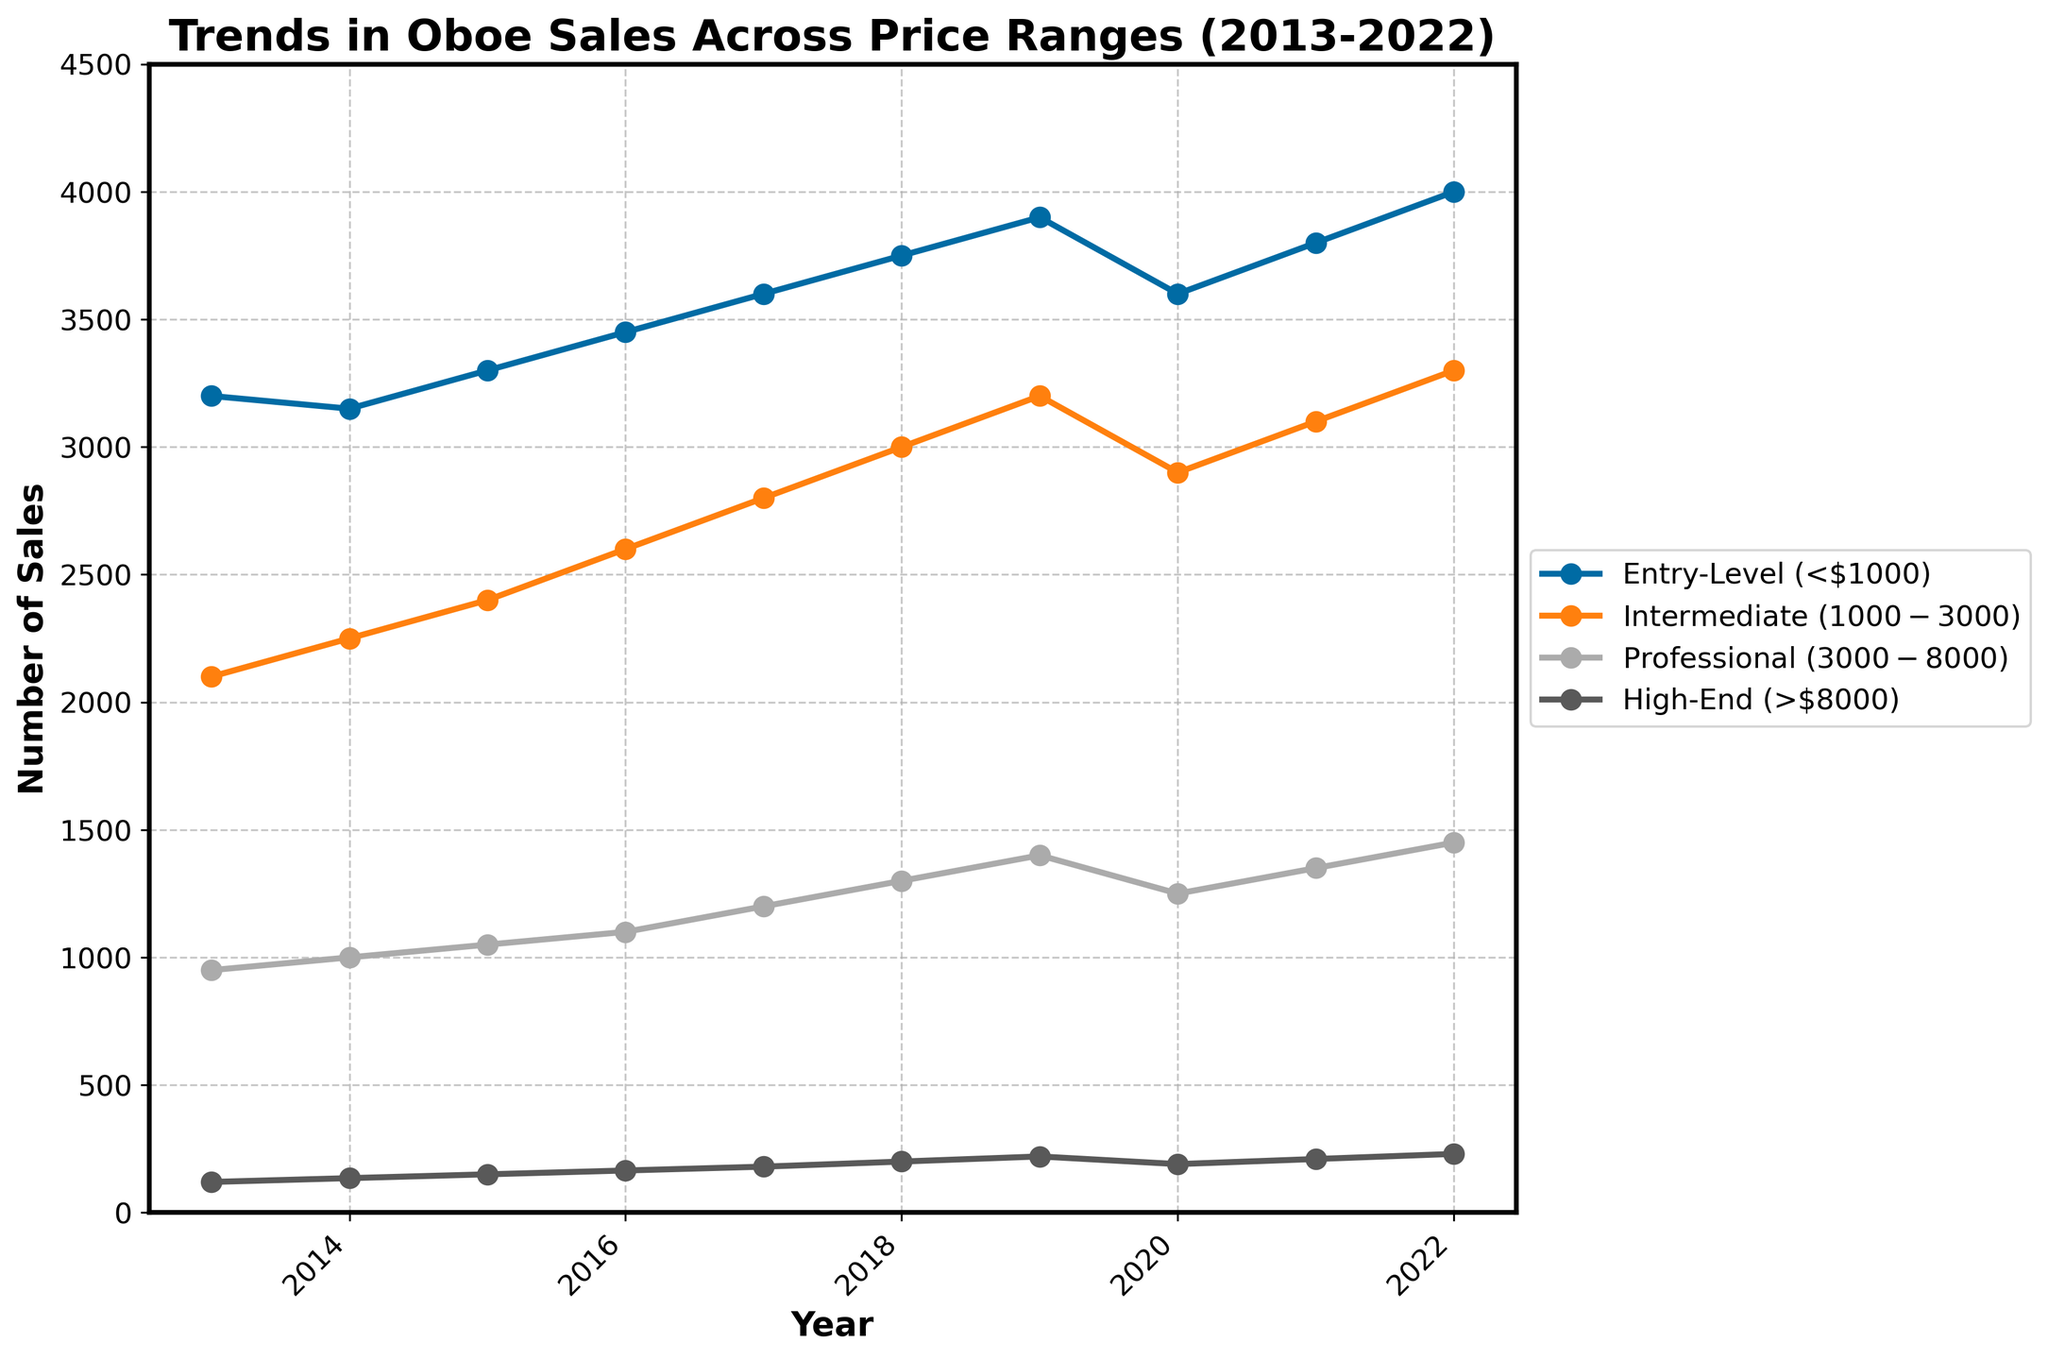When did Entry-Level oboe sales reach their peak during the given period? To find the peak year for Entry-Level oboe sales, look at the respective data line and identify the highest point. In this case, the highest number of entries for Entry-Level sales is 4000 in 2022.
Answer: 2022 Which price range saw the largest increase in sales from 2013 to 2022? To determine the price range with the largest increase in sales, calculate the difference between 2022 and 2013 sales for each price range. Entry-Level increased by 800 (4000-3200), Intermediate by 1200 (3300-2100), Professional by 500 (1450-950), and High-End by 110 (230-120). The Intermediate price range had the largest increase.
Answer: Intermediate ($1000-$3000) By how much did the sales of Professional oboes change from 2019 to 2020? Examine the data points for Professional oboes in 2019 and 2020: 1400 in 2019 and 1250 in 2020. Calculate the difference: 1400 - 1250 = 150.
Answer: Decreased by 150 Which price range had the most stable sales, showing the least change over the years? Stability can be measured by looking at the range of sales data. Calculate the range (max - min) for each price range. Entry-Level: 800, Intermediate: 1200, Professional: 500, High-End: 110. The High-End price range shows the smallest range, indicating the most stability.
Answer: High-End (>$8000) Between which consecutive years did Intermediate oboe sales see the largest increase? Compare the yearly differences for Intermediate oboe sales. Notice the increases: 150 (2013-2014), 150 (2014-2015), 200 (2015-2016), 200 (2016-2017), 200 (2017-2018), 200 (2018-2019), -300 (2019-2020), 200 (2020-2021), 200 (2021-2022). The largest increase is 200 (occurs multiple times but 2015-2016 is the first instance).
Answer: 2015-2016 Were there any years when sales in all price ranges declined? Compare year-to-year data to check for any declines across all price ranges. Examine each year and notice that 2020 shows a decline in all price ranges compared to 2019.
Answer: 2020 How did High-End oboe sales evolve over the decade? Track the sales figures for High-End oboes from 2013 to 2022. The trend shows a consistent increase from 120 in 2013 to 230 in 2022, except for a slight dip in 2020.
Answer: Generally increasing 